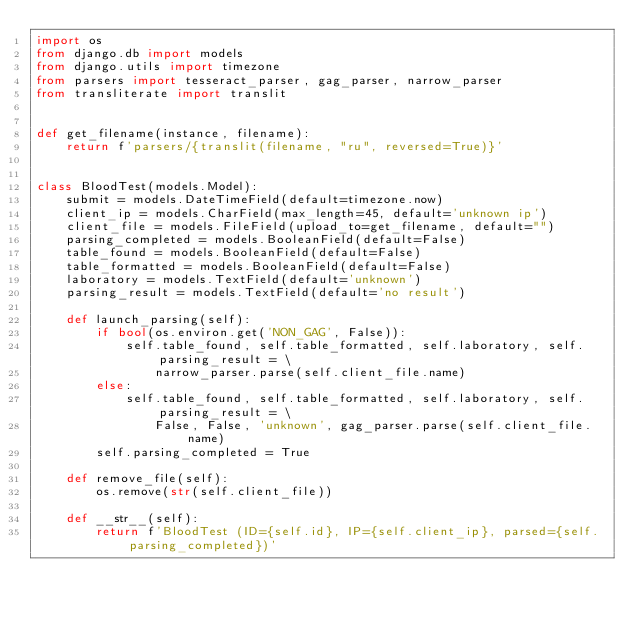Convert code to text. <code><loc_0><loc_0><loc_500><loc_500><_Python_>import os
from django.db import models
from django.utils import timezone
from parsers import tesseract_parser, gag_parser, narrow_parser
from transliterate import translit


def get_filename(instance, filename):
    return f'parsers/{translit(filename, "ru", reversed=True)}'


class BloodTest(models.Model):
    submit = models.DateTimeField(default=timezone.now)
    client_ip = models.CharField(max_length=45, default='unknown ip')
    client_file = models.FileField(upload_to=get_filename, default="")
    parsing_completed = models.BooleanField(default=False)
    table_found = models.BooleanField(default=False)
    table_formatted = models.BooleanField(default=False)
    laboratory = models.TextField(default='unknown')
    parsing_result = models.TextField(default='no result')

    def launch_parsing(self):
        if bool(os.environ.get('NON_GAG', False)):
            self.table_found, self.table_formatted, self.laboratory, self.parsing_result = \
                narrow_parser.parse(self.client_file.name)
        else:
            self.table_found, self.table_formatted, self.laboratory, self.parsing_result = \
                False, False, 'unknown', gag_parser.parse(self.client_file.name)
        self.parsing_completed = True

    def remove_file(self):
        os.remove(str(self.client_file))

    def __str__(self):
        return f'BloodTest (ID={self.id}, IP={self.client_ip}, parsed={self.parsing_completed})'
</code> 